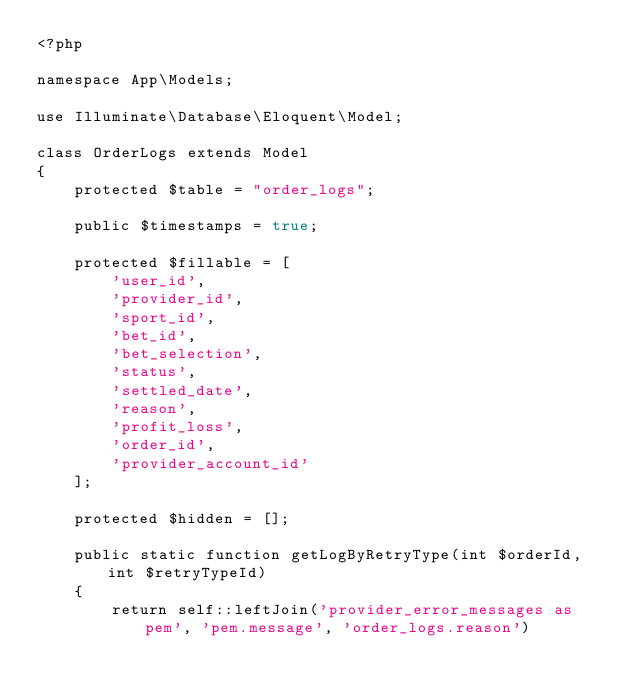Convert code to text. <code><loc_0><loc_0><loc_500><loc_500><_PHP_><?php

namespace App\Models;

use Illuminate\Database\Eloquent\Model;

class OrderLogs extends Model
{
    protected $table = "order_logs";

    public $timestamps = true;

    protected $fillable = [
        'user_id',
        'provider_id',
        'sport_id',
        'bet_id',
        'bet_selection',
        'status',
        'settled_date',
        'reason',
        'profit_loss',
        'order_id',
        'provider_account_id'
    ];

    protected $hidden = [];

    public static function getLogByRetryType(int $orderId, int $retryTypeId)
    {
        return self::leftJoin('provider_error_messages as pem', 'pem.message', 'order_logs.reason')</code> 